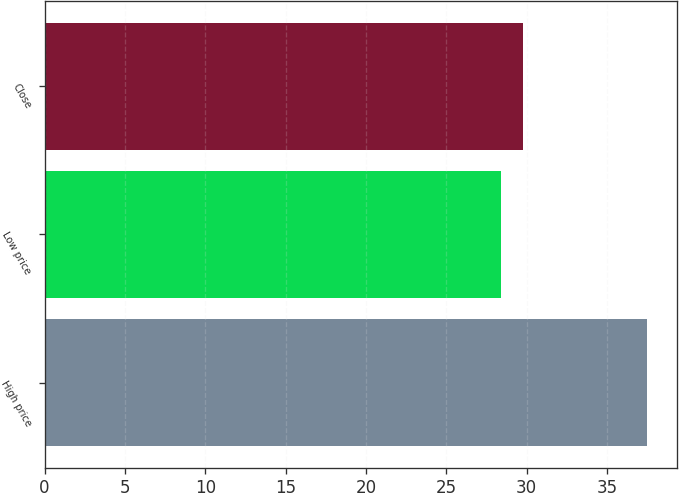Convert chart to OTSL. <chart><loc_0><loc_0><loc_500><loc_500><bar_chart><fcel>High price<fcel>Low price<fcel>Close<nl><fcel>37.5<fcel>28.4<fcel>29.74<nl></chart> 